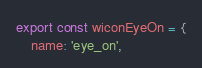<code> <loc_0><loc_0><loc_500><loc_500><_JavaScript_>export const wiconEyeOn = {
    name: 'eye_on',</code> 